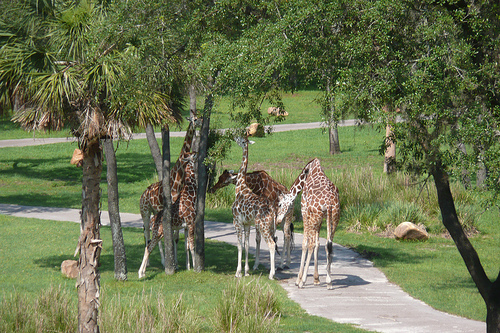Are the giraffes engaged in any particular activity? The giraffes appear to be in a relaxed state, mostly standing and casually interacting with each other, which might indicate socializing or simply enjoying a peaceful moment in their enclosure. 